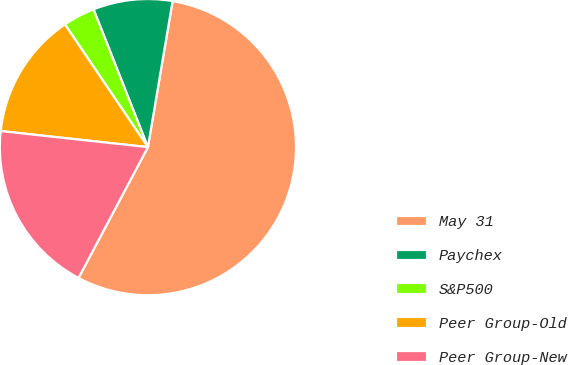<chart> <loc_0><loc_0><loc_500><loc_500><pie_chart><fcel>May 31<fcel>Paychex<fcel>S&P500<fcel>Peer Group-Old<fcel>Peer Group-New<nl><fcel>55.1%<fcel>8.65%<fcel>3.48%<fcel>13.81%<fcel>18.97%<nl></chart> 